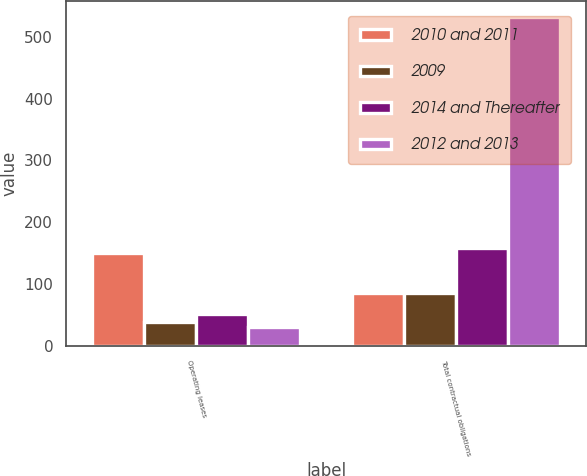Convert chart. <chart><loc_0><loc_0><loc_500><loc_500><stacked_bar_chart><ecel><fcel>Operating leases<fcel>Total contractual obligations<nl><fcel>2010 and 2011<fcel>149.3<fcel>85.9<nl><fcel>2009<fcel>38.2<fcel>85.9<nl><fcel>2014 and Thereafter<fcel>51<fcel>158.9<nl><fcel>2012 and 2013<fcel>30.2<fcel>531.8<nl></chart> 